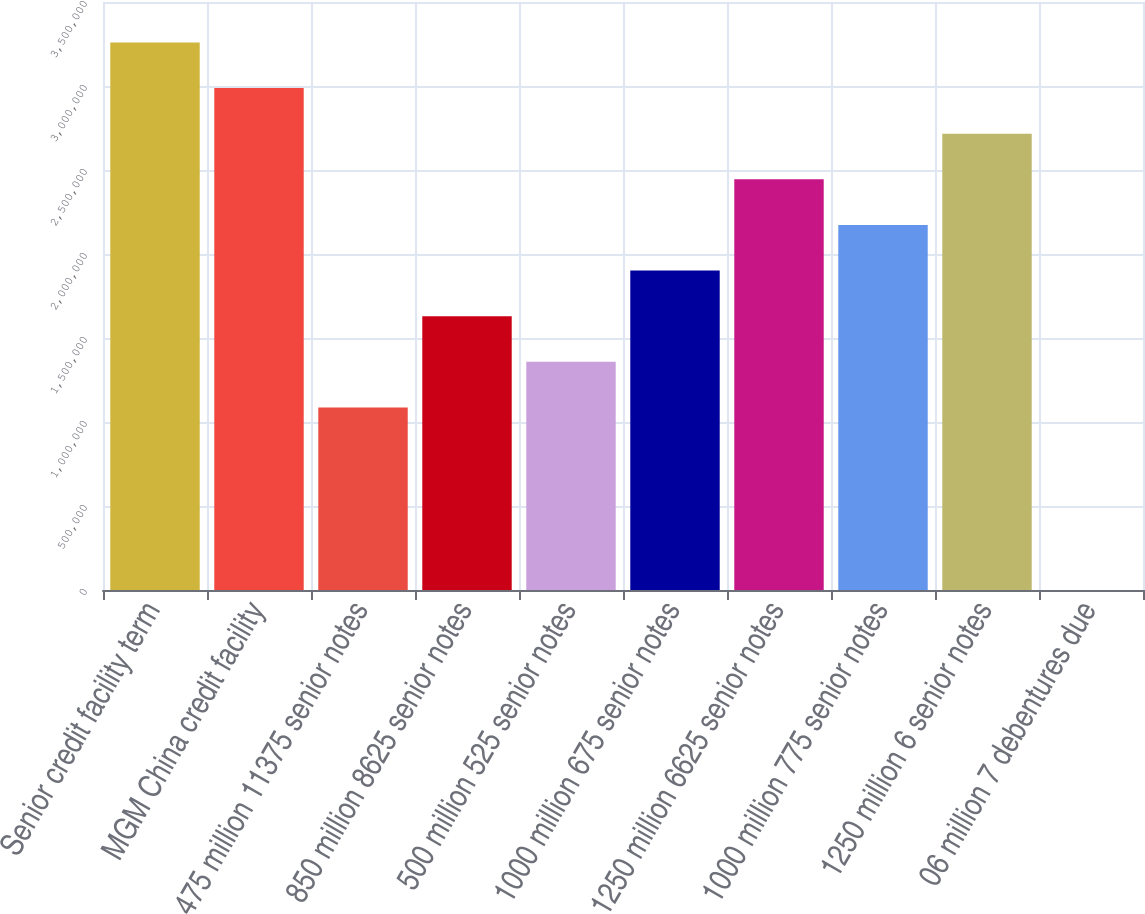Convert chart. <chart><loc_0><loc_0><loc_500><loc_500><bar_chart><fcel>Senior credit facility term<fcel>MGM China credit facility<fcel>475 million 11375 senior notes<fcel>850 million 8625 senior notes<fcel>500 million 525 senior notes<fcel>1000 million 675 senior notes<fcel>1250 million 6625 senior notes<fcel>1000 million 775 senior notes<fcel>1250 million 6 senior notes<fcel>06 million 7 debentures due<nl><fcel>3.25909e+06<fcel>2.98754e+06<fcel>1.08673e+06<fcel>1.62982e+06<fcel>1.35828e+06<fcel>1.90137e+06<fcel>2.44446e+06<fcel>2.17291e+06<fcel>2.716e+06<fcel>552<nl></chart> 